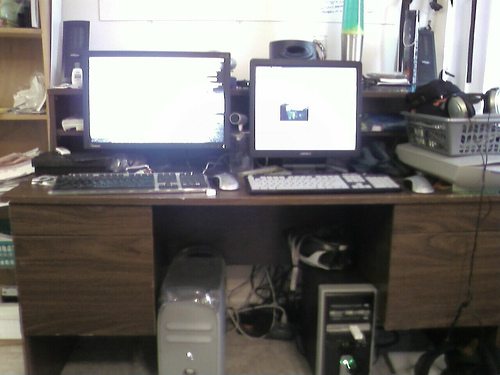<image>What are the computers used for? It is ambiguous what the computers are used for. They could be used for gaming, work, music, or entertainment. What are the computers used for? I don't know what the computers are used for. They can be used for gaming, work, or entertainment. 